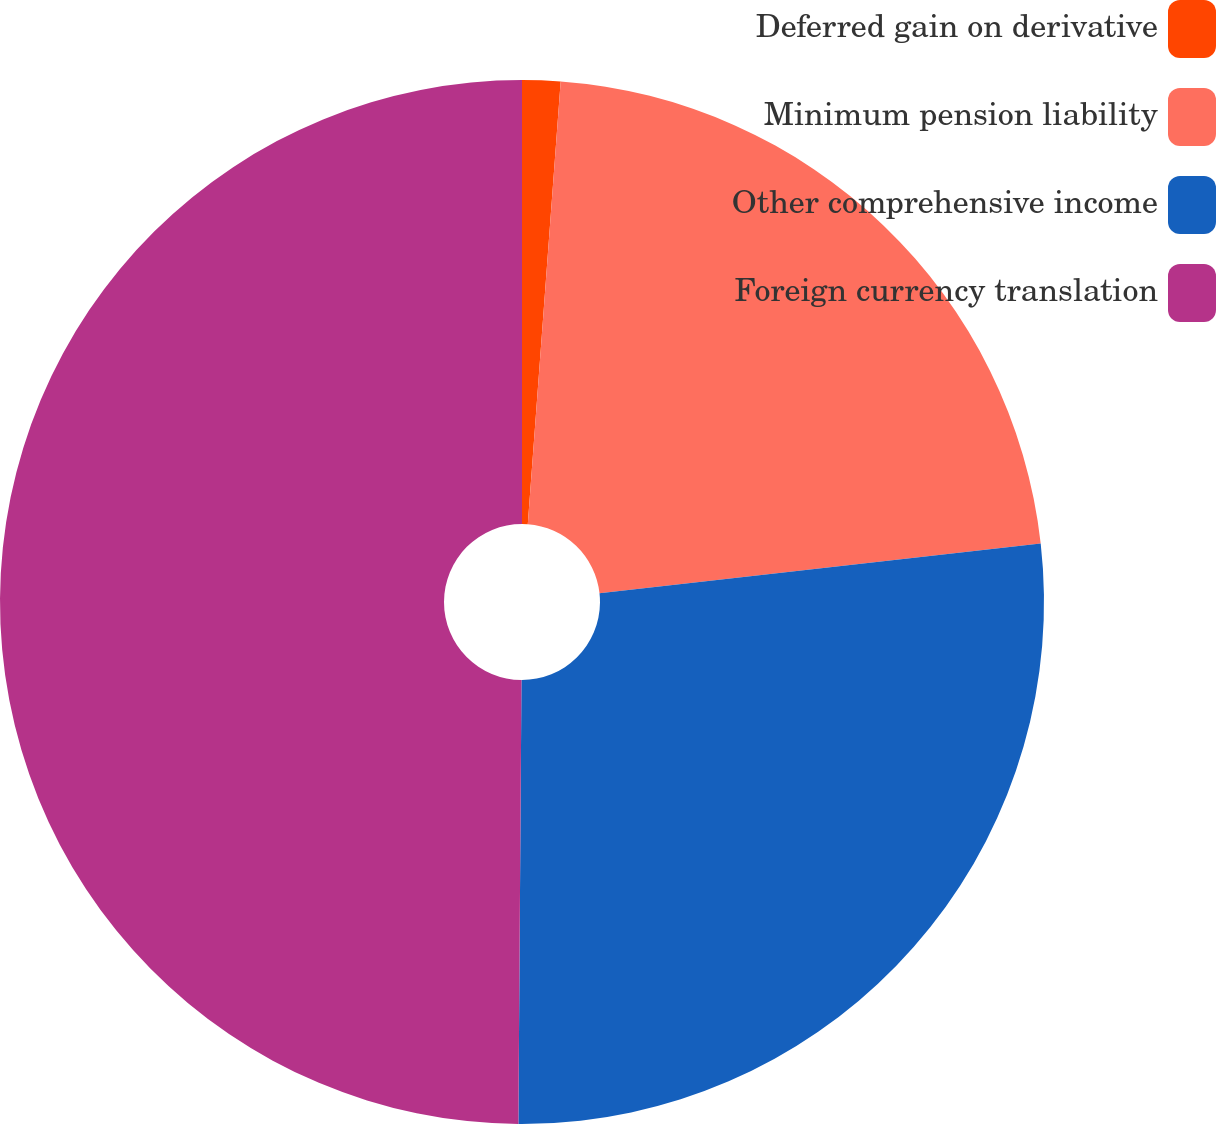Convert chart to OTSL. <chart><loc_0><loc_0><loc_500><loc_500><pie_chart><fcel>Deferred gain on derivative<fcel>Minimum pension liability<fcel>Other comprehensive income<fcel>Foreign currency translation<nl><fcel>1.18%<fcel>22.03%<fcel>26.9%<fcel>49.89%<nl></chart> 